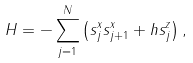Convert formula to latex. <formula><loc_0><loc_0><loc_500><loc_500>H = - \sum _ { j = 1 } ^ { N } \left ( s _ { j } ^ { x } s _ { j + 1 } ^ { x } + h s _ { j } ^ { z } \right ) ,</formula> 